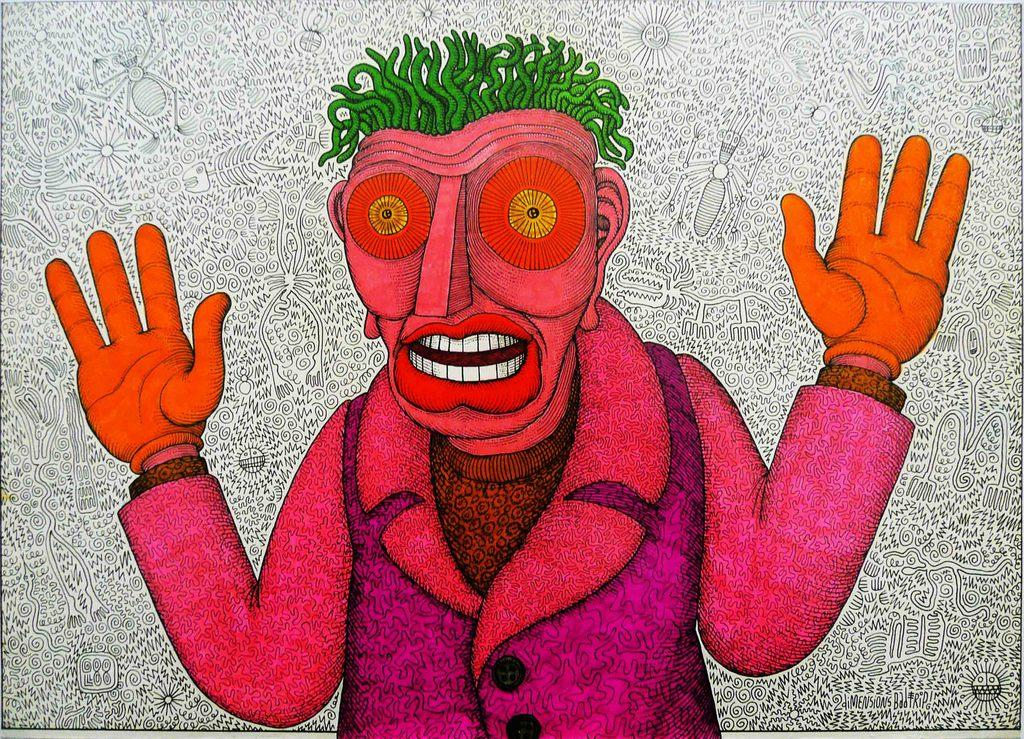What type of image is being described? The image is animated. Can you describe the main subject in the image? There is a person in the image. What does the background of the image resemble? The background of the image looks like a wall. What type of hook can be seen hanging on the wall in the image? There is no hook present in the image. Is there a bike visible in the image? There is no bike present in the image. What type of paste is being used by the person in the image? There is no paste or any indication of its use in the image. 